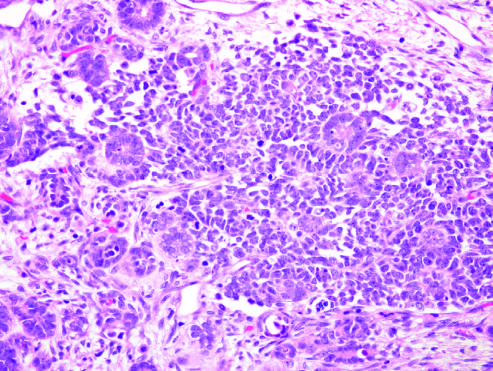does large, flat cells with small nuclei intersperse primitive tubules, represent the epithelial component?
Answer the question using a single word or phrase. No 